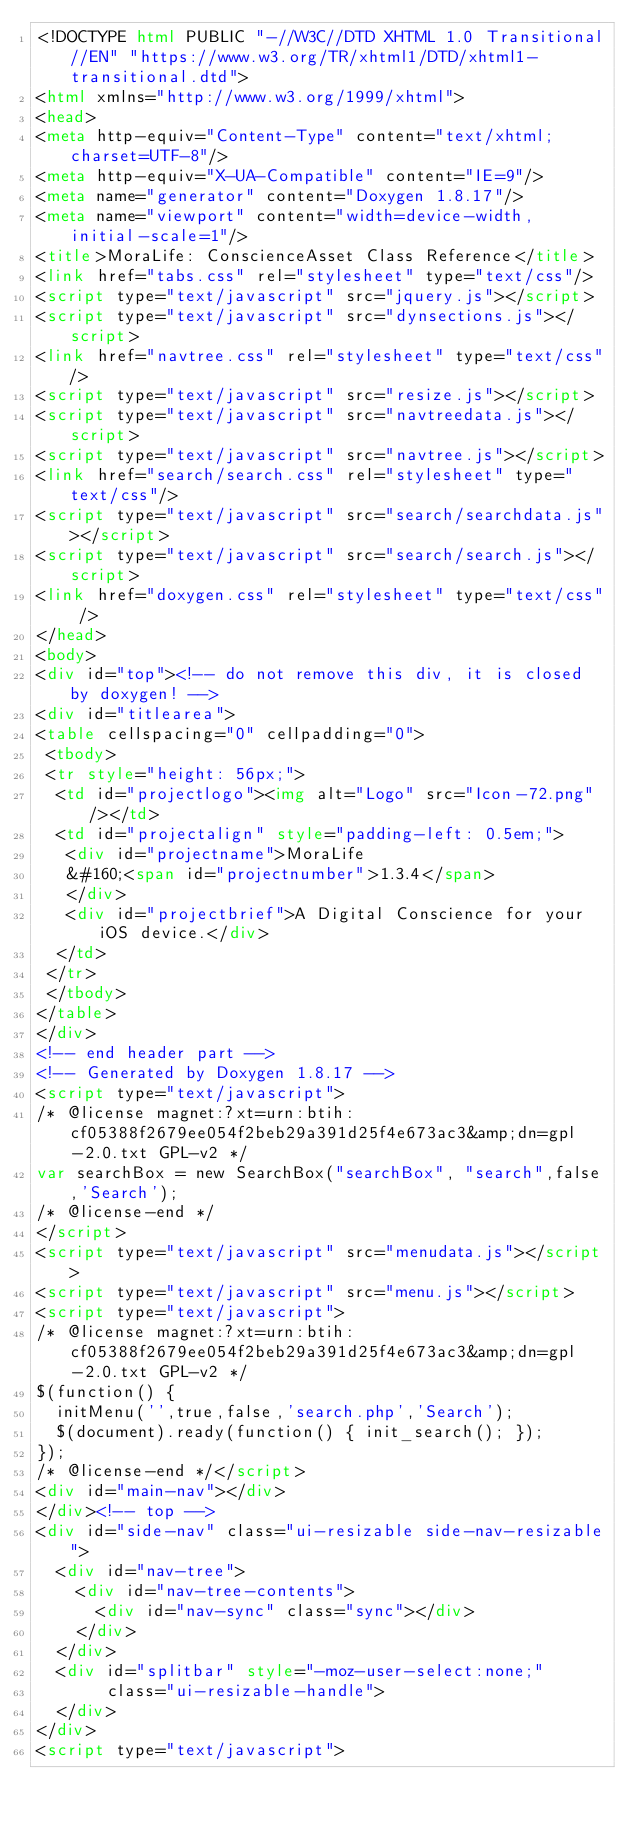Convert code to text. <code><loc_0><loc_0><loc_500><loc_500><_HTML_><!DOCTYPE html PUBLIC "-//W3C//DTD XHTML 1.0 Transitional//EN" "https://www.w3.org/TR/xhtml1/DTD/xhtml1-transitional.dtd">
<html xmlns="http://www.w3.org/1999/xhtml">
<head>
<meta http-equiv="Content-Type" content="text/xhtml;charset=UTF-8"/>
<meta http-equiv="X-UA-Compatible" content="IE=9"/>
<meta name="generator" content="Doxygen 1.8.17"/>
<meta name="viewport" content="width=device-width, initial-scale=1"/>
<title>MoraLife: ConscienceAsset Class Reference</title>
<link href="tabs.css" rel="stylesheet" type="text/css"/>
<script type="text/javascript" src="jquery.js"></script>
<script type="text/javascript" src="dynsections.js"></script>
<link href="navtree.css" rel="stylesheet" type="text/css"/>
<script type="text/javascript" src="resize.js"></script>
<script type="text/javascript" src="navtreedata.js"></script>
<script type="text/javascript" src="navtree.js"></script>
<link href="search/search.css" rel="stylesheet" type="text/css"/>
<script type="text/javascript" src="search/searchdata.js"></script>
<script type="text/javascript" src="search/search.js"></script>
<link href="doxygen.css" rel="stylesheet" type="text/css" />
</head>
<body>
<div id="top"><!-- do not remove this div, it is closed by doxygen! -->
<div id="titlearea">
<table cellspacing="0" cellpadding="0">
 <tbody>
 <tr style="height: 56px;">
  <td id="projectlogo"><img alt="Logo" src="Icon-72.png"/></td>
  <td id="projectalign" style="padding-left: 0.5em;">
   <div id="projectname">MoraLife
   &#160;<span id="projectnumber">1.3.4</span>
   </div>
   <div id="projectbrief">A Digital Conscience for your iOS device.</div>
  </td>
 </tr>
 </tbody>
</table>
</div>
<!-- end header part -->
<!-- Generated by Doxygen 1.8.17 -->
<script type="text/javascript">
/* @license magnet:?xt=urn:btih:cf05388f2679ee054f2beb29a391d25f4e673ac3&amp;dn=gpl-2.0.txt GPL-v2 */
var searchBox = new SearchBox("searchBox", "search",false,'Search');
/* @license-end */
</script>
<script type="text/javascript" src="menudata.js"></script>
<script type="text/javascript" src="menu.js"></script>
<script type="text/javascript">
/* @license magnet:?xt=urn:btih:cf05388f2679ee054f2beb29a391d25f4e673ac3&amp;dn=gpl-2.0.txt GPL-v2 */
$(function() {
  initMenu('',true,false,'search.php','Search');
  $(document).ready(function() { init_search(); });
});
/* @license-end */</script>
<div id="main-nav"></div>
</div><!-- top -->
<div id="side-nav" class="ui-resizable side-nav-resizable">
  <div id="nav-tree">
    <div id="nav-tree-contents">
      <div id="nav-sync" class="sync"></div>
    </div>
  </div>
  <div id="splitbar" style="-moz-user-select:none;" 
       class="ui-resizable-handle">
  </div>
</div>
<script type="text/javascript"></code> 